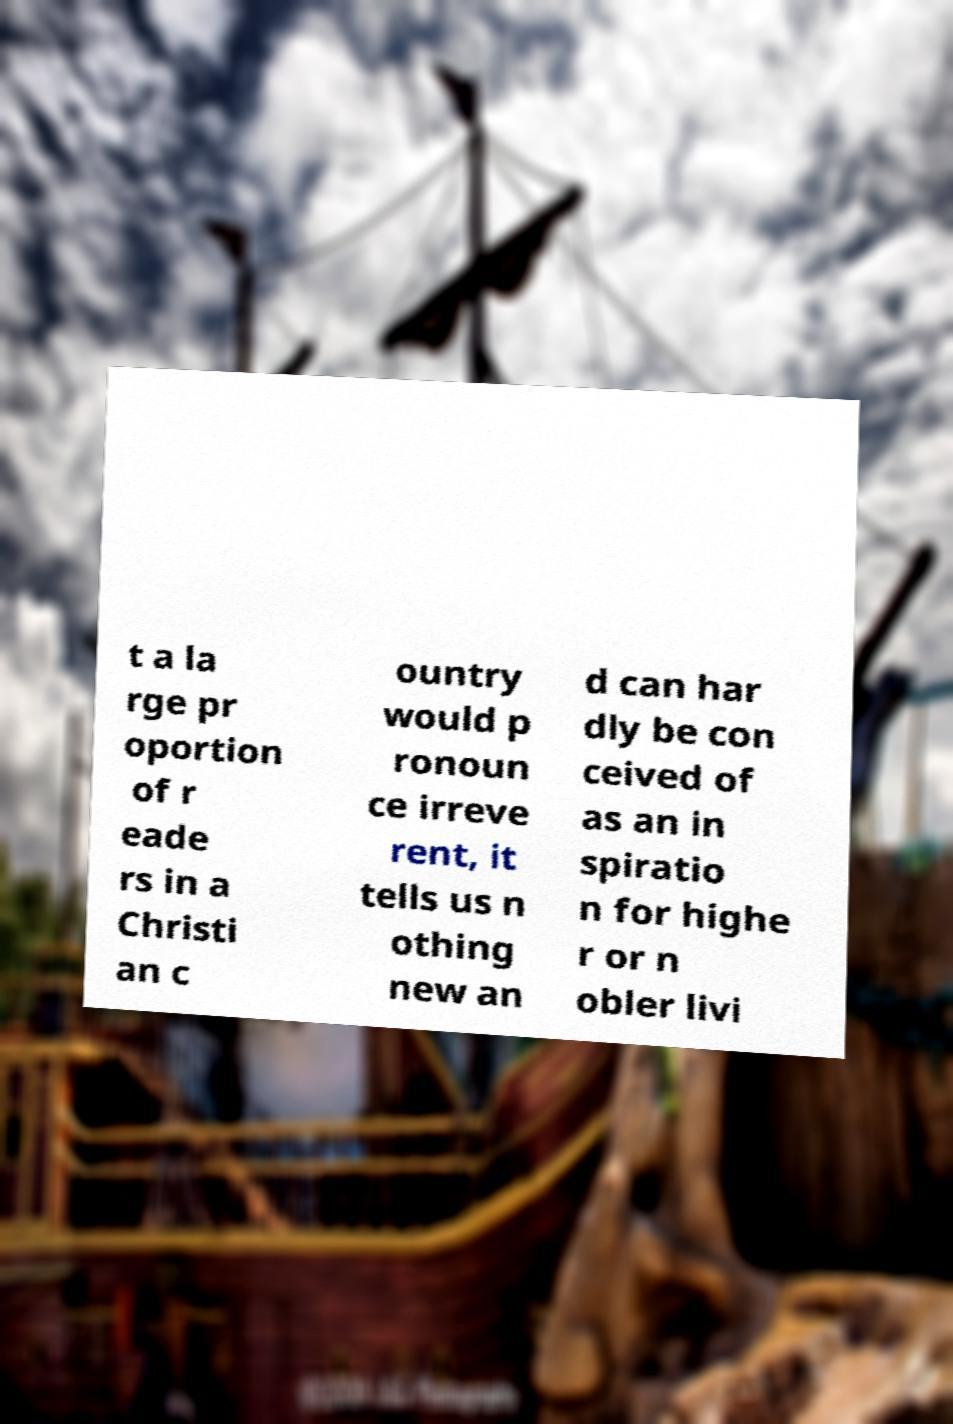Please read and relay the text visible in this image. What does it say? t a la rge pr oportion of r eade rs in a Christi an c ountry would p ronoun ce irreve rent, it tells us n othing new an d can har dly be con ceived of as an in spiratio n for highe r or n obler livi 